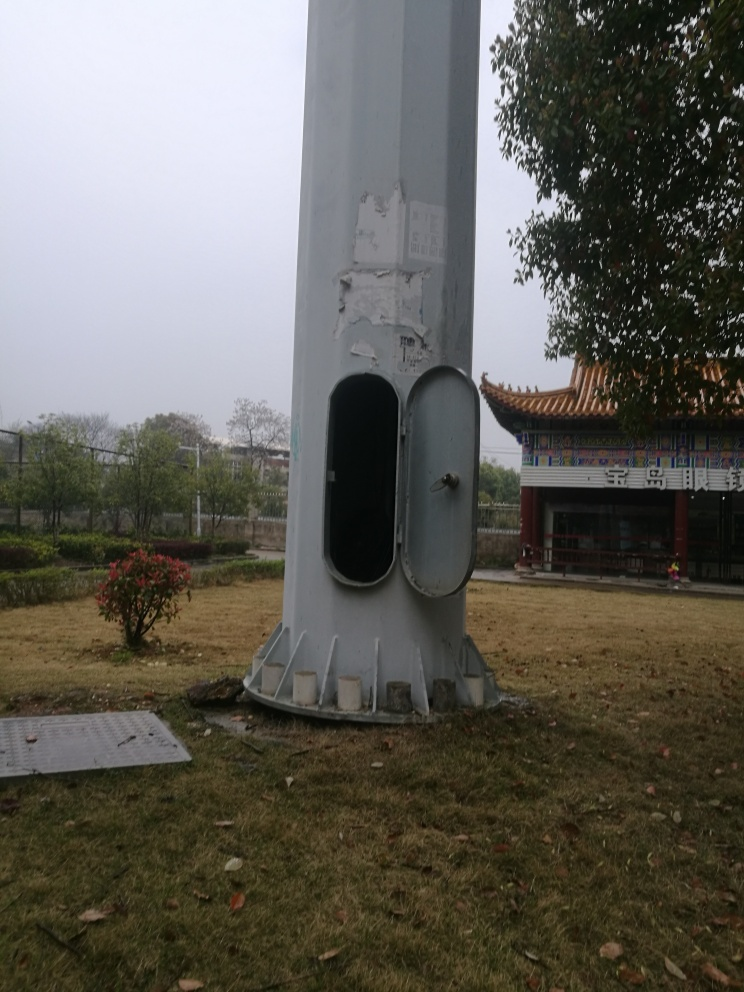Does the image preserve texture details?
A. No
B. Partially
C. Yes
Answer with the option's letter from the given choices directly.
 C. 